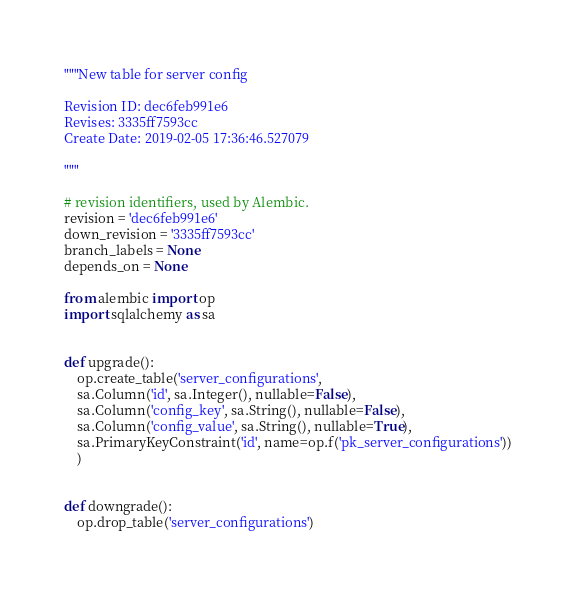<code> <loc_0><loc_0><loc_500><loc_500><_Python_>"""New table for server config

Revision ID: dec6feb991e6
Revises: 3335ff7593cc
Create Date: 2019-02-05 17:36:46.527079

"""

# revision identifiers, used by Alembic.
revision = 'dec6feb991e6'
down_revision = '3335ff7593cc'
branch_labels = None
depends_on = None

from alembic import op
import sqlalchemy as sa


def upgrade():
    op.create_table('server_configurations',
    sa.Column('id', sa.Integer(), nullable=False),
    sa.Column('config_key', sa.String(), nullable=False),
    sa.Column('config_value', sa.String(), nullable=True),
    sa.PrimaryKeyConstraint('id', name=op.f('pk_server_configurations'))
    )


def downgrade():
    op.drop_table('server_configurations')
</code> 